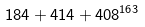Convert formula to latex. <formula><loc_0><loc_0><loc_500><loc_500>1 8 4 + 4 1 4 + 4 0 8 ^ { 1 6 3 }</formula> 